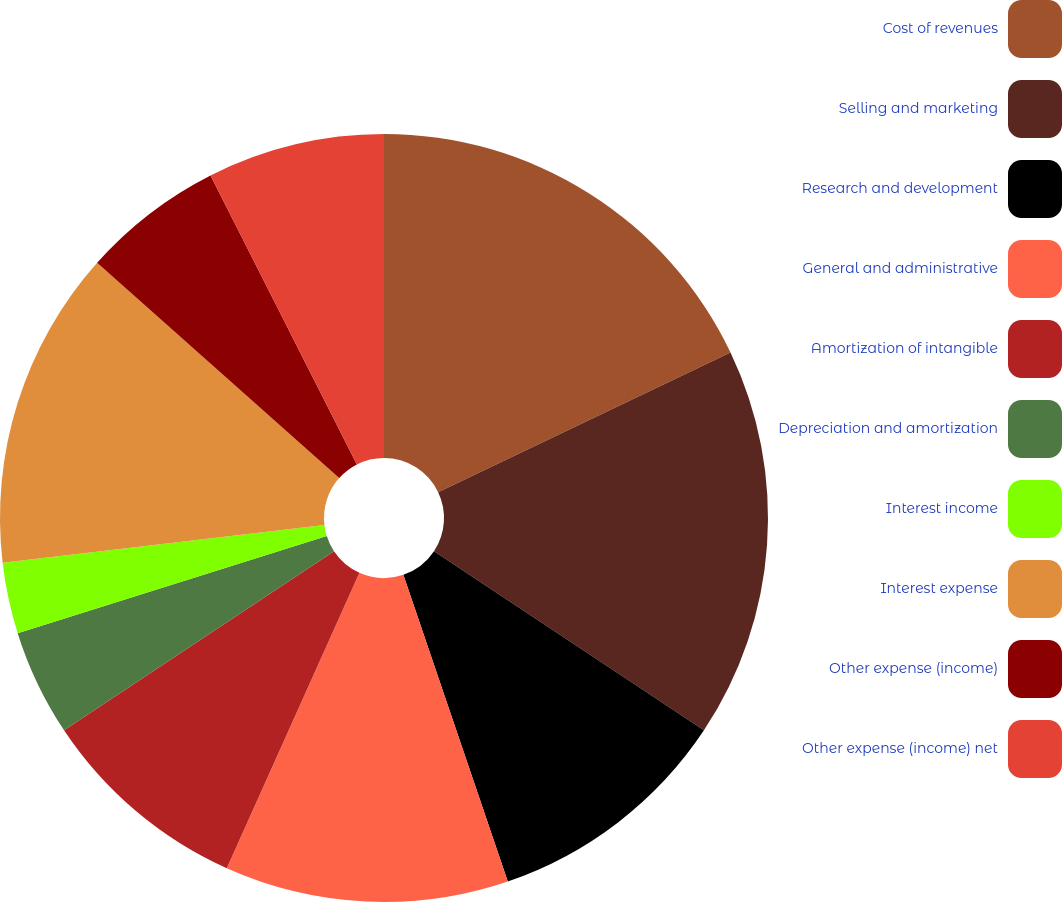<chart> <loc_0><loc_0><loc_500><loc_500><pie_chart><fcel>Cost of revenues<fcel>Selling and marketing<fcel>Research and development<fcel>General and administrative<fcel>Amortization of intangible<fcel>Depreciation and amortization<fcel>Interest income<fcel>Interest expense<fcel>Other expense (income)<fcel>Other expense (income) net<nl><fcel>17.91%<fcel>16.42%<fcel>10.45%<fcel>11.94%<fcel>8.96%<fcel>4.48%<fcel>2.99%<fcel>13.43%<fcel>5.97%<fcel>7.46%<nl></chart> 